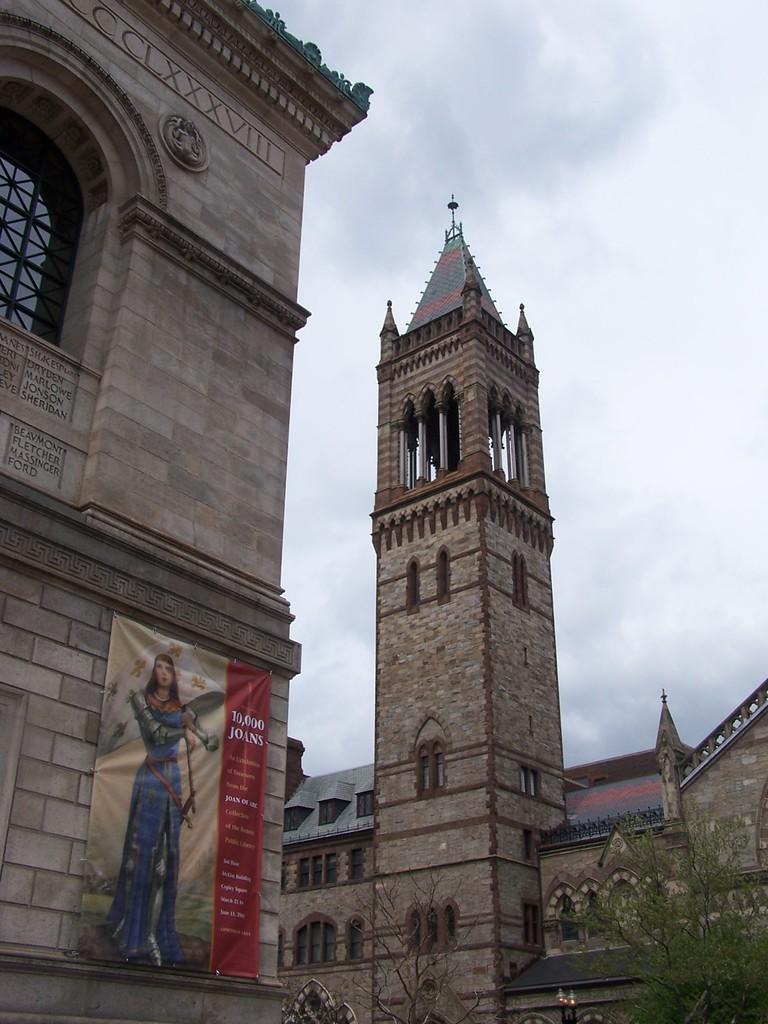How would you summarize this image in a sentence or two? In this image, we can see buildings, tower, pillars, glass windows, banner, trees, lights and walls. Background there is a sky. 